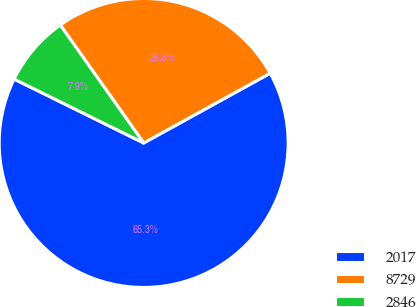Convert chart. <chart><loc_0><loc_0><loc_500><loc_500><pie_chart><fcel>2017<fcel>8729<fcel>2846<nl><fcel>65.31%<fcel>26.78%<fcel>7.91%<nl></chart> 